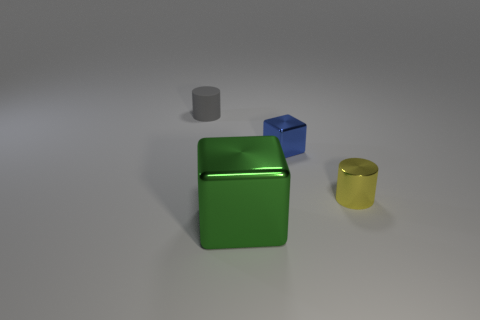Can you describe the lighting and shadows in the scene? The lighting appears to be coming from above, casting soft shadows to the right of the objects. This indirect lighting creates a soft appearance without harsh shadows, indicating a diffuse light source. 